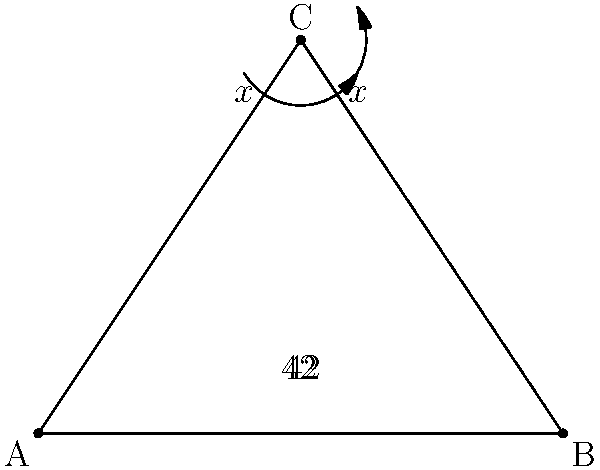In the University of Leicester's coat of arms, there's a triangular shape with congruent angles. If two of the angles in this triangle are 42°, what is the measure of the angle at the top of the triangle, denoted as $x$ in the diagram? Let's solve this step-by-step:

1) First, recall that the sum of angles in a triangle is always 180°.

2) We're given that two angles in the triangle are 42°.

3) Let's set up an equation:
   $42° + 42° + x = 180°$

4) Simplify:
   $84° + x = 180°$

5) Subtract 84° from both sides:
   $x = 180° - 84°$

6) Solve for $x$:
   $x = 96°$

7) Therefore, the angle at the top of the triangle is 96°.

8) We can verify this by noting that the two 42° angles are congruent (equal), and the 96° angle at the top bisects the triangle, creating two congruent 48° angles.
Answer: 96° 